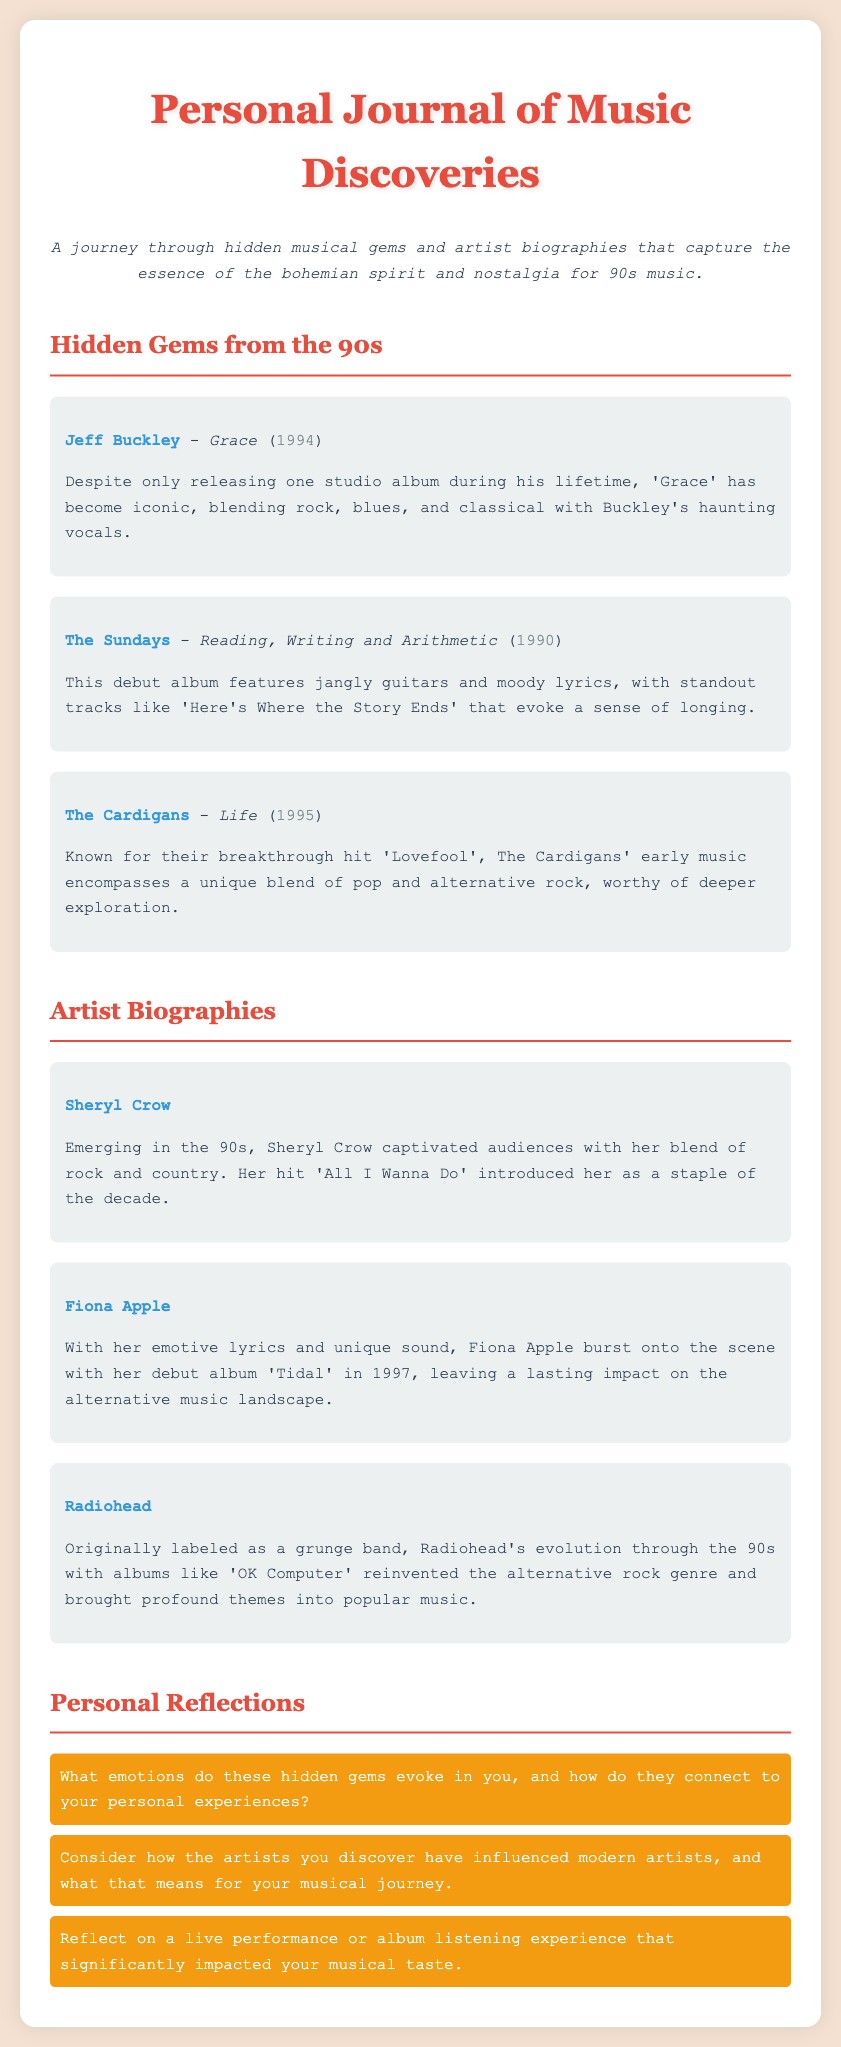What is the title of the first hidden gem listed? The document provides a hidden gem section, with Jeff Buckley's 'Grace' listed first.
Answer: Grace Who is the artist of the album 'Reading, Writing and Arithmetic'? The artist of the album is mentioned in the document, which is The Sundays.
Answer: The Sundays In what year was 'Grace' released? The year of release for the album 'Grace' is stated in the document.
Answer: 1994 Which artist is described as emerging in the 90s? The document highlights Sheryl Crow as an artist who captivated audiences during the 90s.
Answer: Sheryl Crow What is a significant hit by Fiona Apple mentioned in the document? The document states Fiona Apple's debut album 'Tidal' and mentions its impact on alternative music but does not specifically list a hit in this section.
Answer: Tidal How many hidden gems from the 90s are listed in the document? The document lists three hidden gems under the 90s section.
Answer: Three What is one aspect of the personal reflections prompts? The prompts ask for emotional connections to the music discovered, emphasizing personal experiences.
Answer: Emotions Which artist's evolution through the 90s reinvented the alternative rock genre? The document refers to Radiohead's significant impact and evolution in the 90s.
Answer: Radiohead 